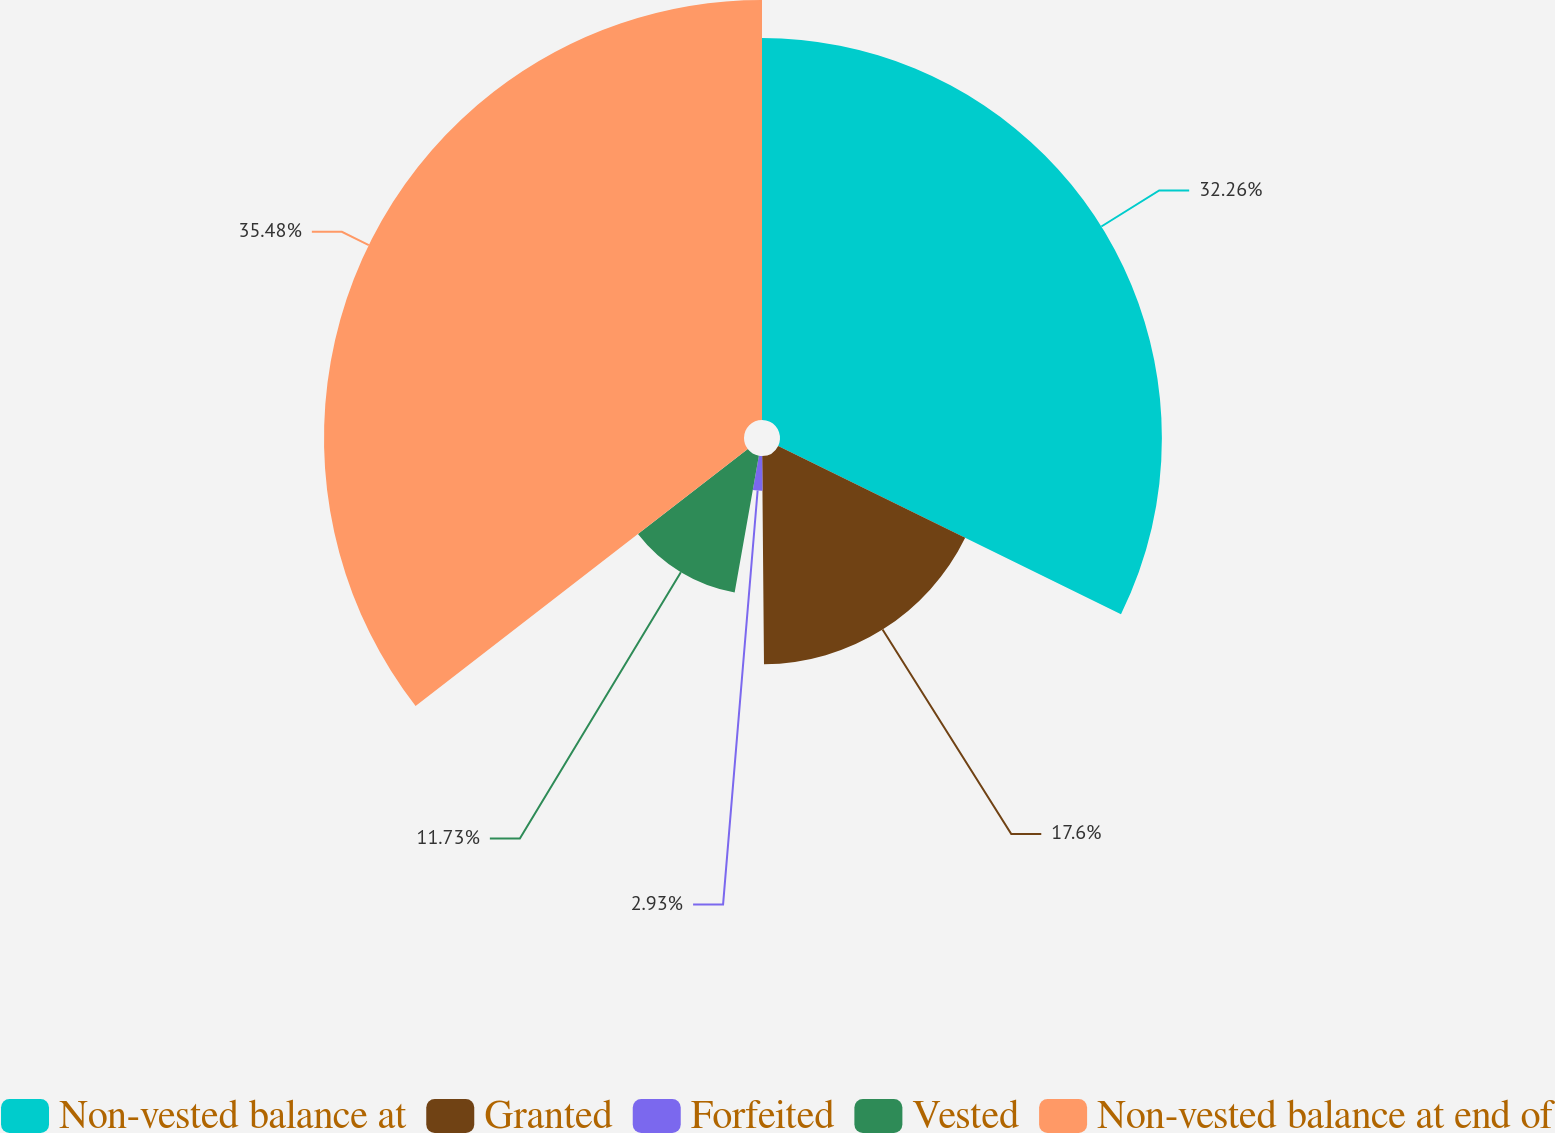Convert chart to OTSL. <chart><loc_0><loc_0><loc_500><loc_500><pie_chart><fcel>Non-vested balance at<fcel>Granted<fcel>Forfeited<fcel>Vested<fcel>Non-vested balance at end of<nl><fcel>32.26%<fcel>17.6%<fcel>2.93%<fcel>11.73%<fcel>35.48%<nl></chart> 